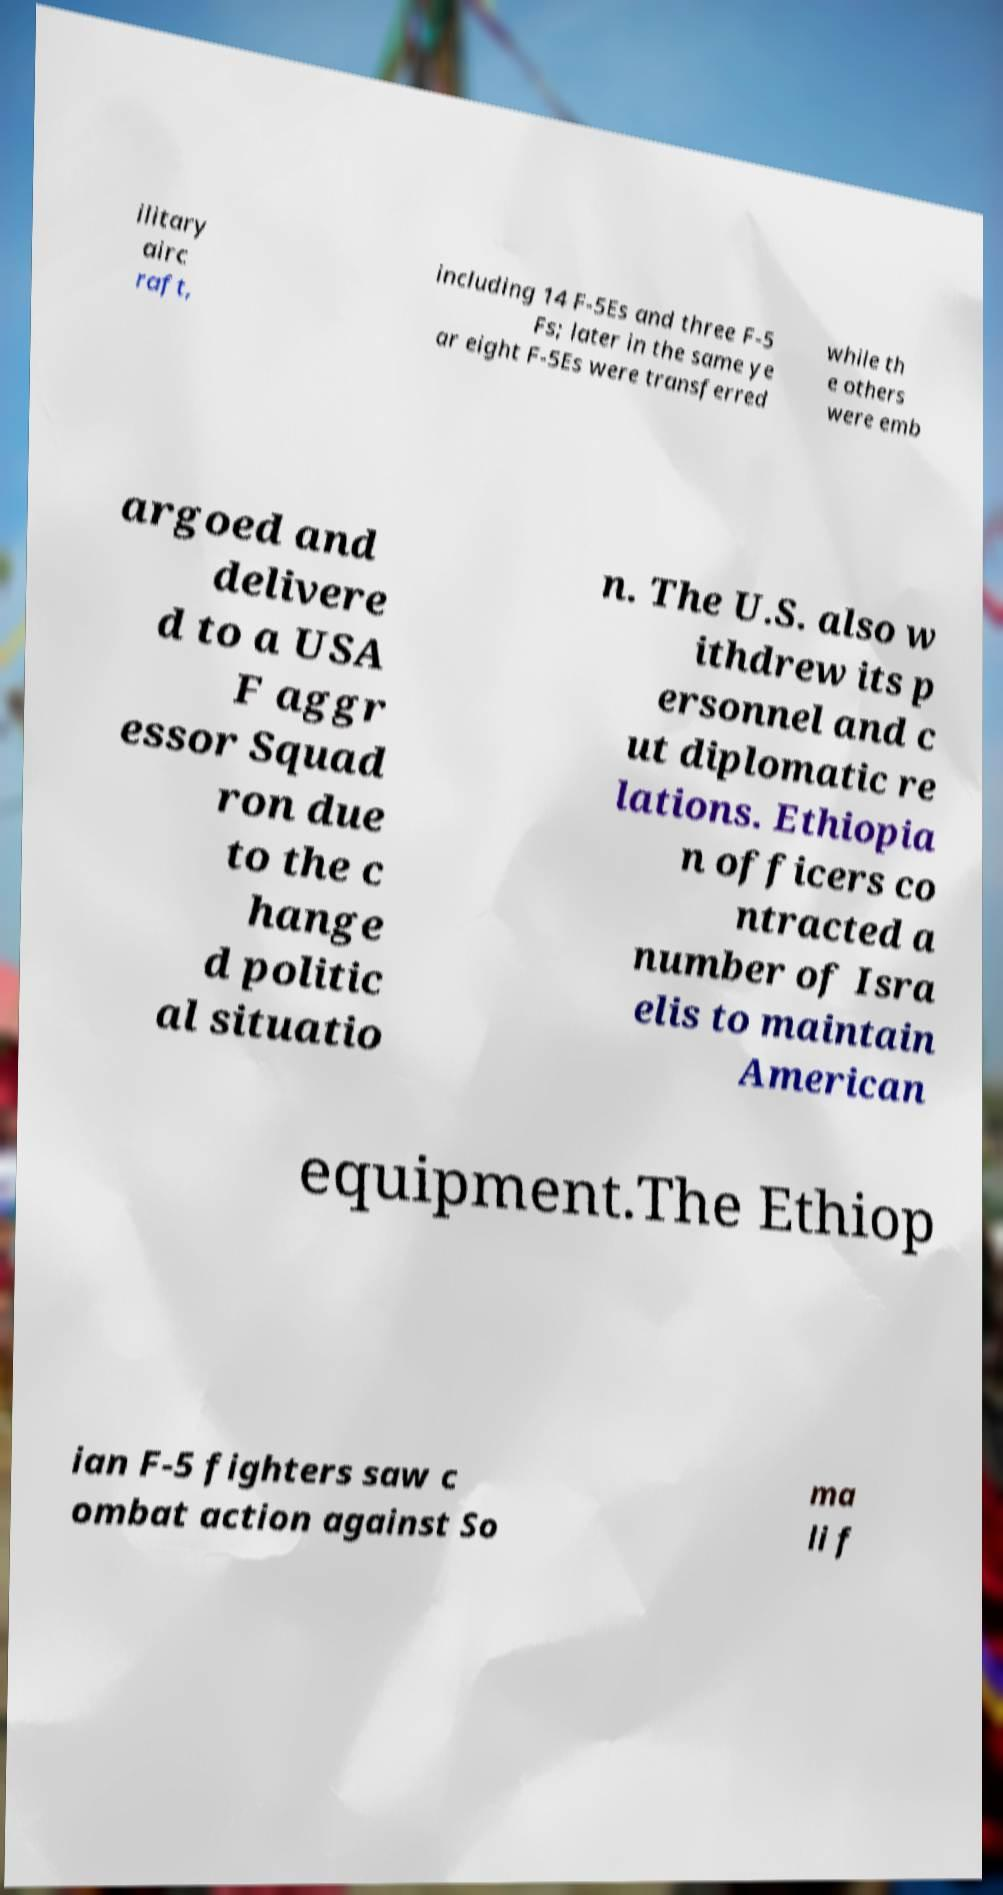Please read and relay the text visible in this image. What does it say? ilitary airc raft, including 14 F-5Es and three F-5 Fs; later in the same ye ar eight F-5Es were transferred while th e others were emb argoed and delivere d to a USA F aggr essor Squad ron due to the c hange d politic al situatio n. The U.S. also w ithdrew its p ersonnel and c ut diplomatic re lations. Ethiopia n officers co ntracted a number of Isra elis to maintain American equipment.The Ethiop ian F-5 fighters saw c ombat action against So ma li f 